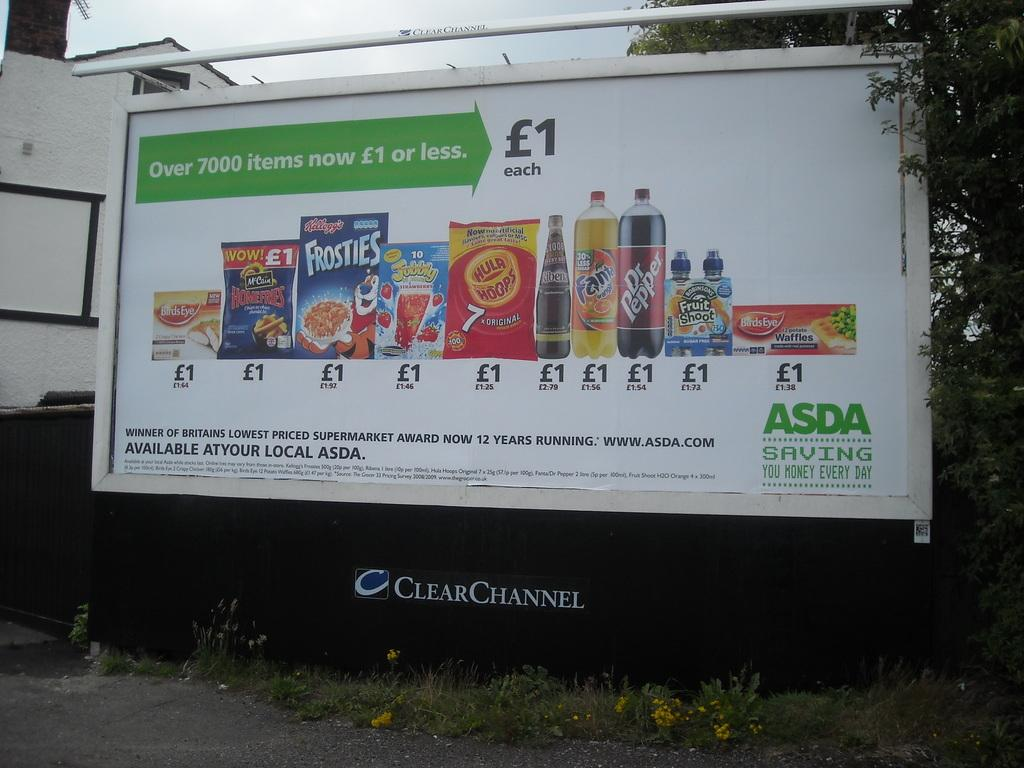<image>
Summarize the visual content of the image. a billboard that says 'over 7000 items now 1 or less' 